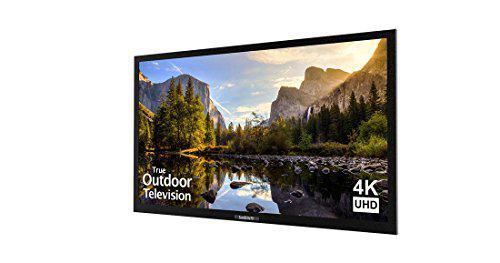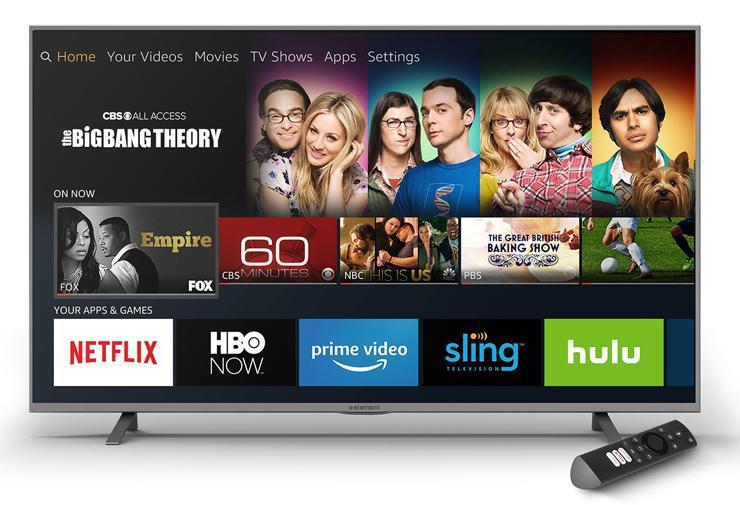The first image is the image on the left, the second image is the image on the right. Considering the images on both sides, is "Exactly one television has end stands." valid? Answer yes or no. Yes. The first image is the image on the left, the second image is the image on the right. For the images shown, is this caption "Each television shows a wordless nature scene." true? Answer yes or no. No. 